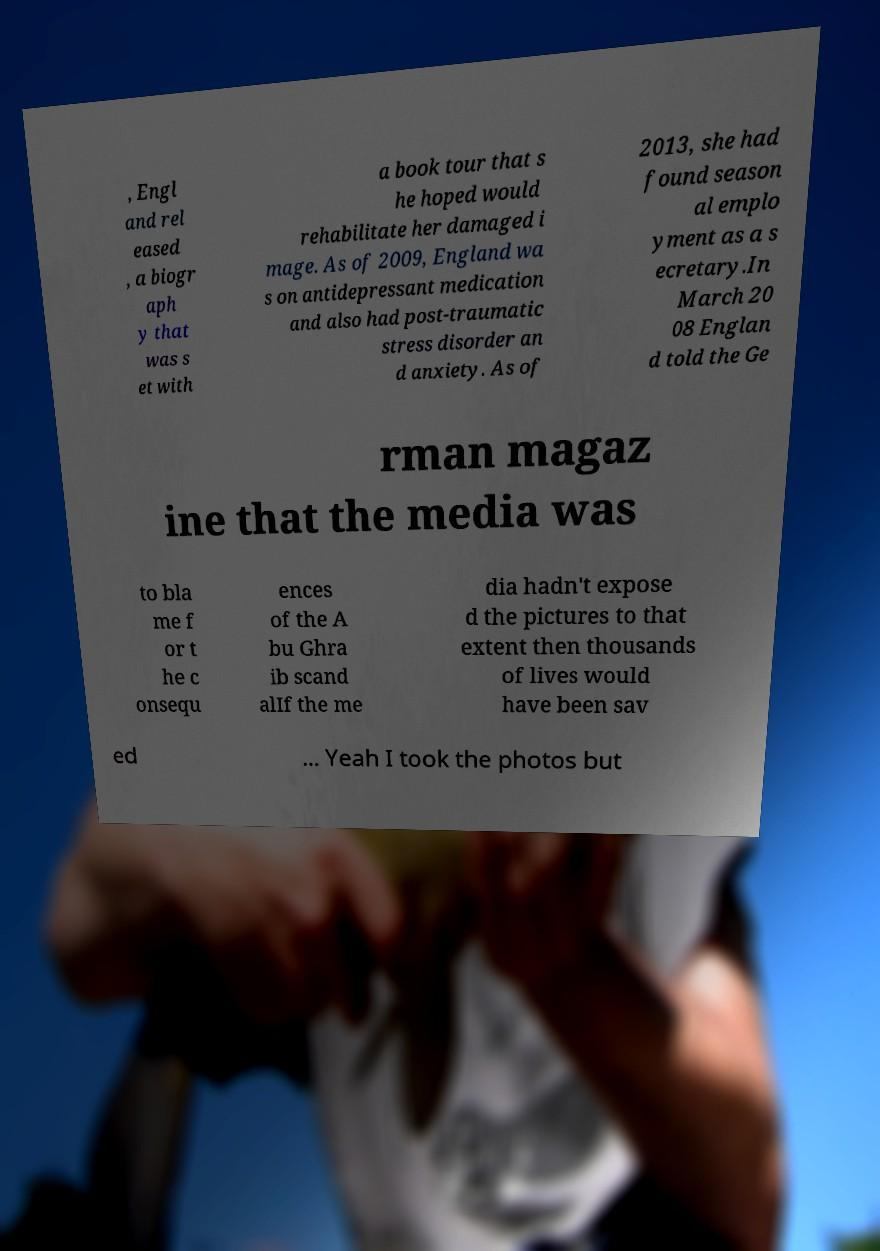Could you extract and type out the text from this image? , Engl and rel eased , a biogr aph y that was s et with a book tour that s he hoped would rehabilitate her damaged i mage. As of 2009, England wa s on antidepressant medication and also had post-traumatic stress disorder an d anxiety. As of 2013, she had found season al emplo yment as a s ecretary.In March 20 08 Englan d told the Ge rman magaz ine that the media was to bla me f or t he c onsequ ences of the A bu Ghra ib scand alIf the me dia hadn't expose d the pictures to that extent then thousands of lives would have been sav ed ... Yeah I took the photos but 